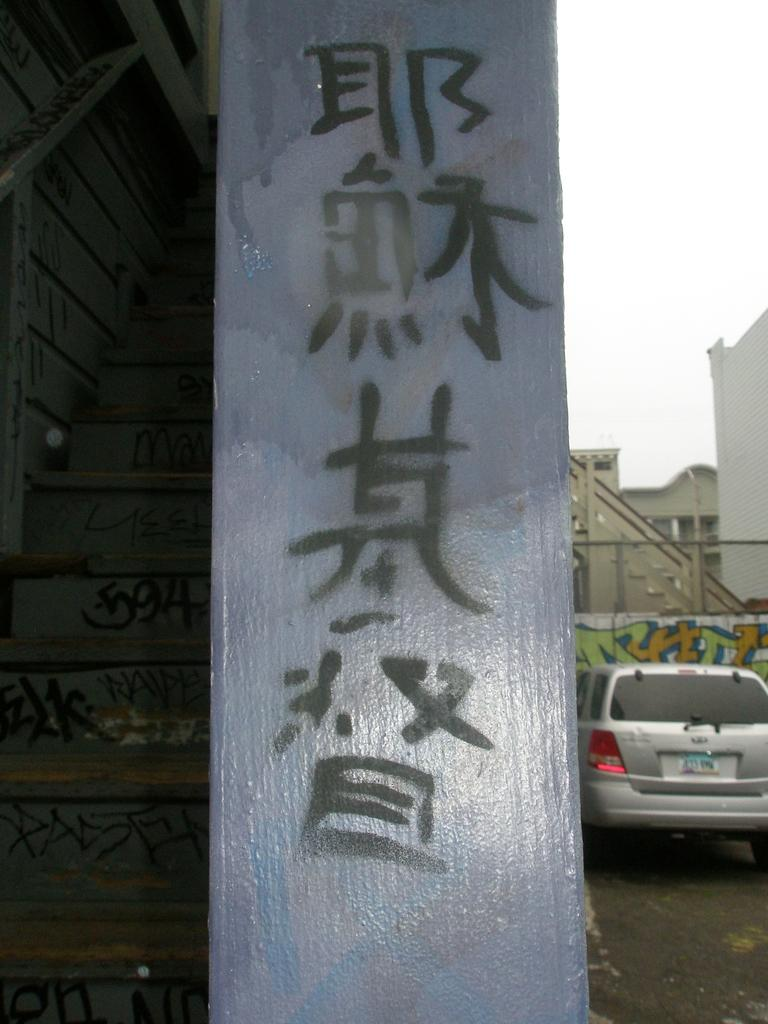What is located in the foreground of the image? There is a pole and a car in the foreground of the image. What can be seen in the background of the image? There are buildings in the background of the image. What type of glass is being used to hold the quince in the image? There is no glass or quince present in the image. How many arms are visible in the image? There are no arms visible in the image. 